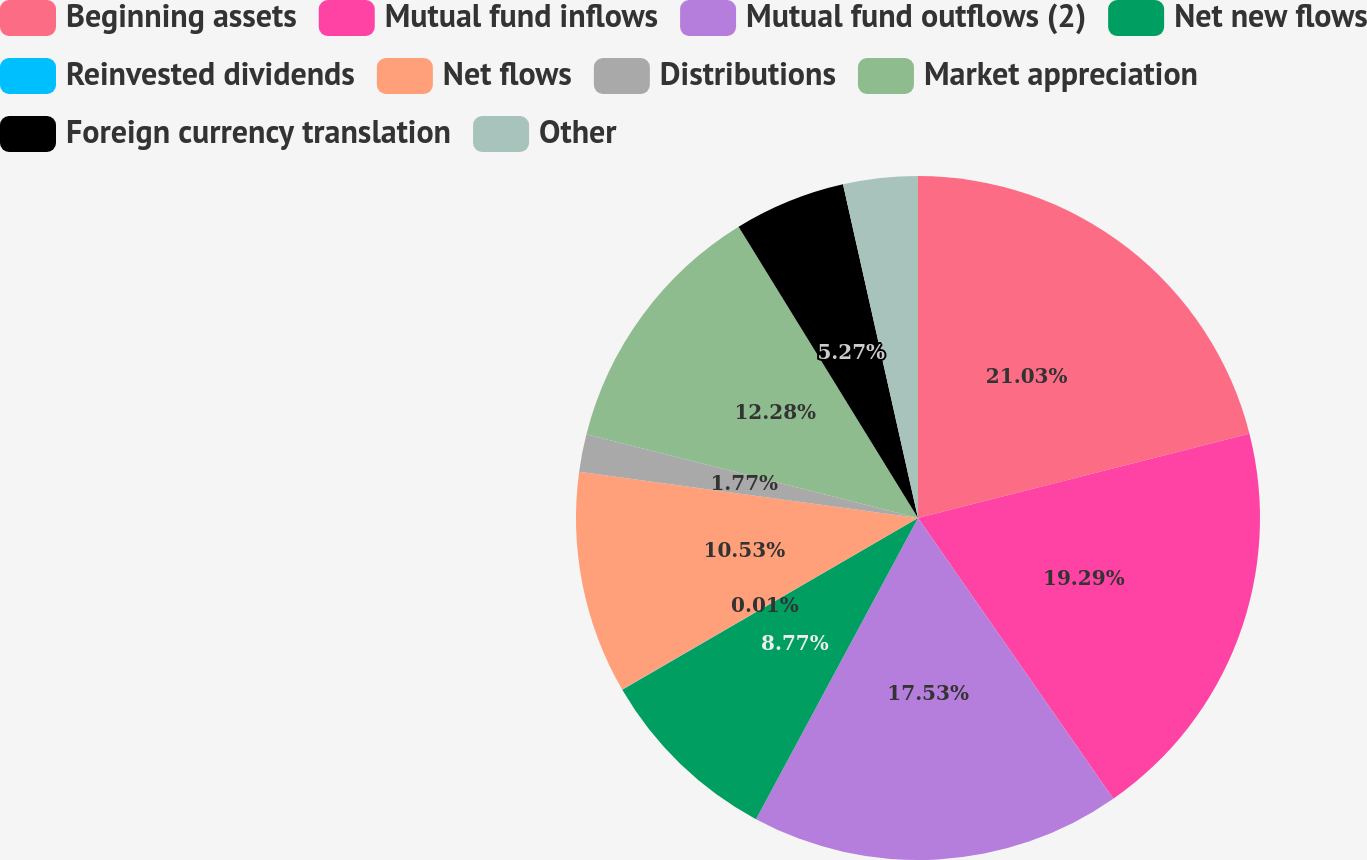Convert chart to OTSL. <chart><loc_0><loc_0><loc_500><loc_500><pie_chart><fcel>Beginning assets<fcel>Mutual fund inflows<fcel>Mutual fund outflows (2)<fcel>Net new flows<fcel>Reinvested dividends<fcel>Net flows<fcel>Distributions<fcel>Market appreciation<fcel>Foreign currency translation<fcel>Other<nl><fcel>21.04%<fcel>19.29%<fcel>17.53%<fcel>8.77%<fcel>0.01%<fcel>10.53%<fcel>1.77%<fcel>12.28%<fcel>5.27%<fcel>3.52%<nl></chart> 